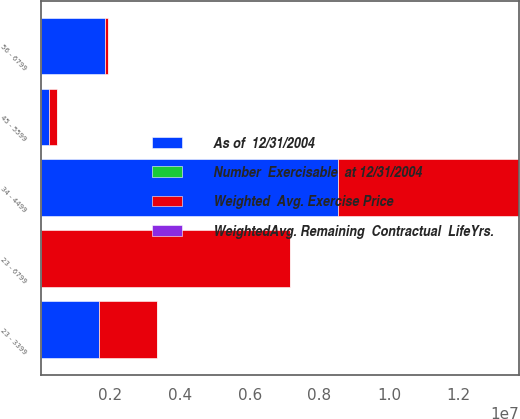Convert chart. <chart><loc_0><loc_0><loc_500><loc_500><stacked_bar_chart><ecel><fcel>23 - 3399<fcel>34 - 4499<fcel>45 - 5599<fcel>56 - 6799<fcel>23 - 6799<nl><fcel>As of  12/31/2004<fcel>1.67443e+06<fcel>8.54752e+06<fcel>230445<fcel>1.85768e+06<fcel>58.64<nl><fcel>Number  Exercisable  at 12/31/2004<fcel>5<fcel>7.1<fcel>5.6<fcel>9.1<fcel>7.1<nl><fcel>WeightedAvg. Remaining  Contractual  LifeYrs.<fcel>26.28<fcel>41.09<fcel>49.61<fcel>58.64<fcel>41.88<nl><fcel>Weighted  Avg. Exercise Price<fcel>1.67443e+06<fcel>5.19549e+06<fcel>222378<fcel>70583<fcel>7.16288e+06<nl></chart> 